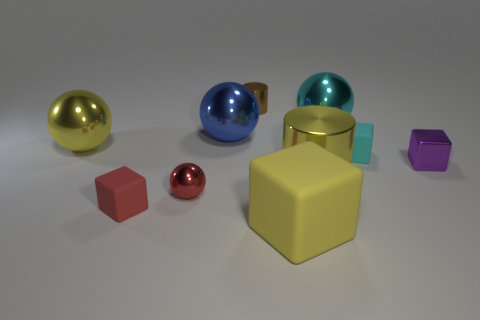Subtract 1 spheres. How many spheres are left? 3 Subtract all cylinders. How many objects are left? 8 Add 8 metal cubes. How many metal cubes exist? 9 Subtract 0 green cylinders. How many objects are left? 10 Subtract all purple metal objects. Subtract all big blue spheres. How many objects are left? 8 Add 6 tiny purple objects. How many tiny purple objects are left? 7 